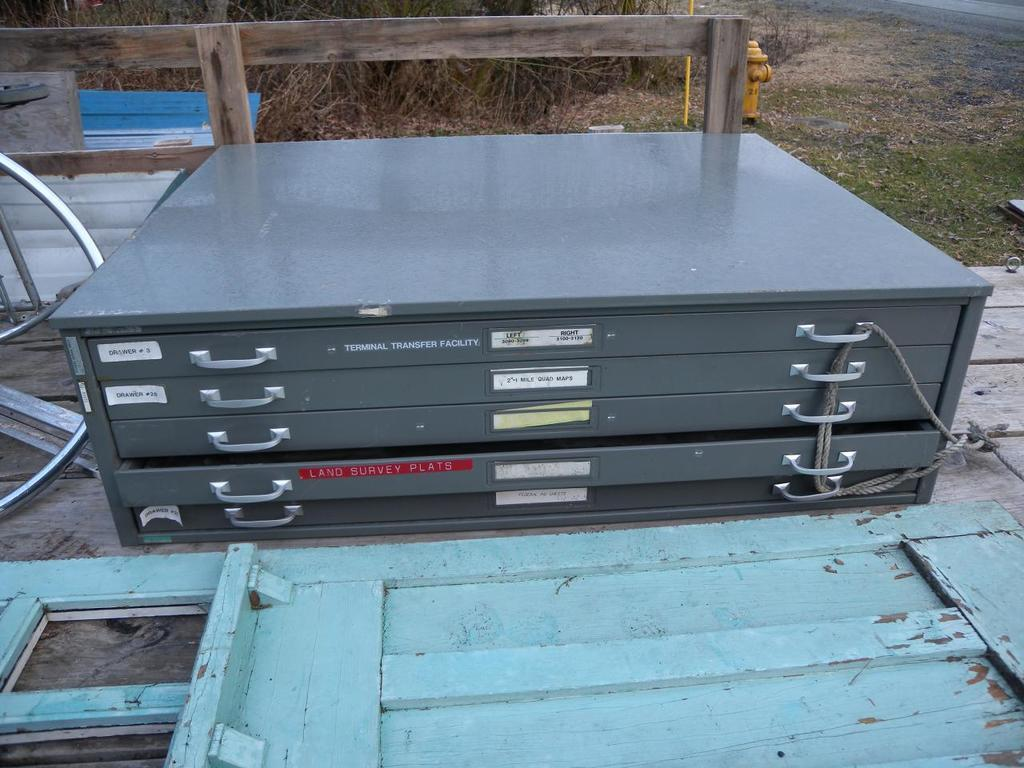<image>
Give a short and clear explanation of the subsequent image. Flat container outdoors with a sticker that says "Drawer 3" near the top left. 